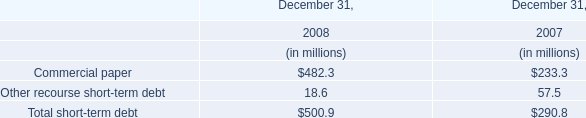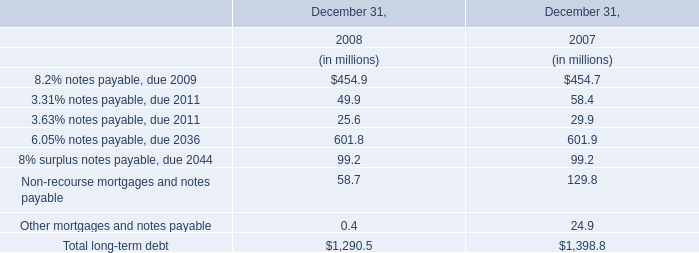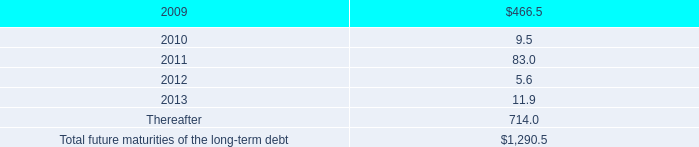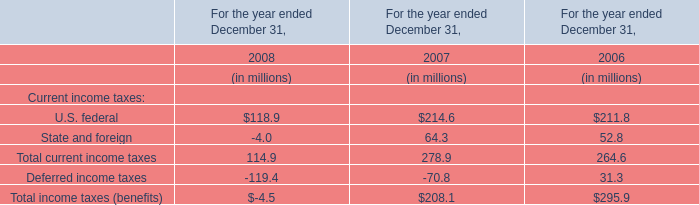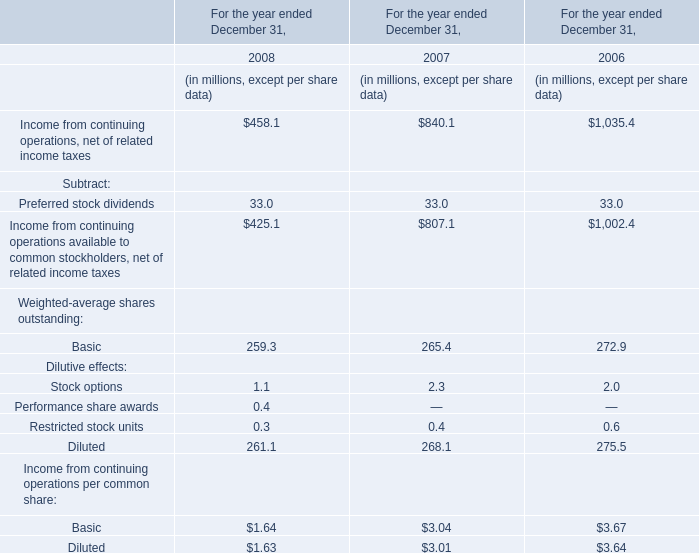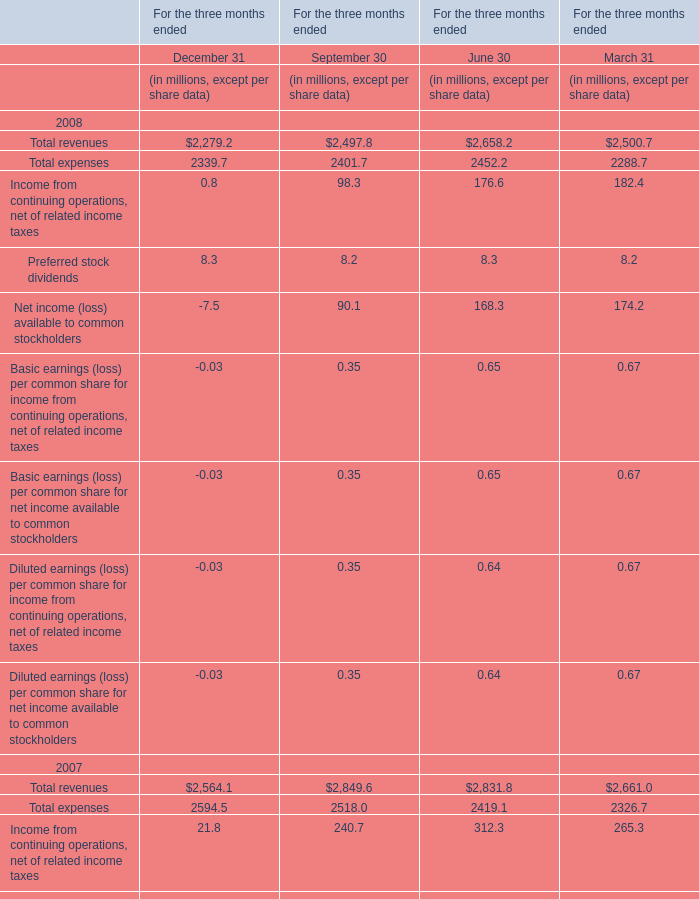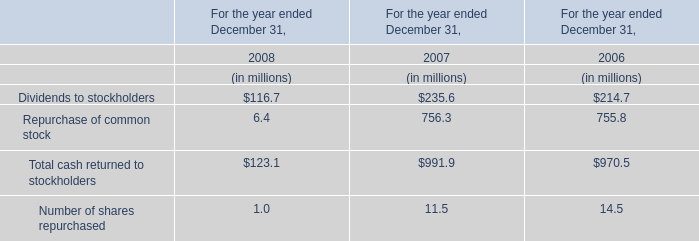In the year with largest amount of Income from continuing operations, net of related income taxes, what's the increasing rate of Basic ? 
Computations: ((265.4 - 272.9) / 265.4)
Answer: -0.02826. 